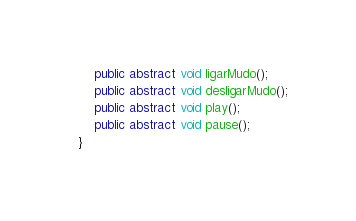<code> <loc_0><loc_0><loc_500><loc_500><_Java_>    public abstract void ligarMudo();
    public abstract void desligarMudo();
    public abstract void play();
    public abstract void pause();
}
</code> 